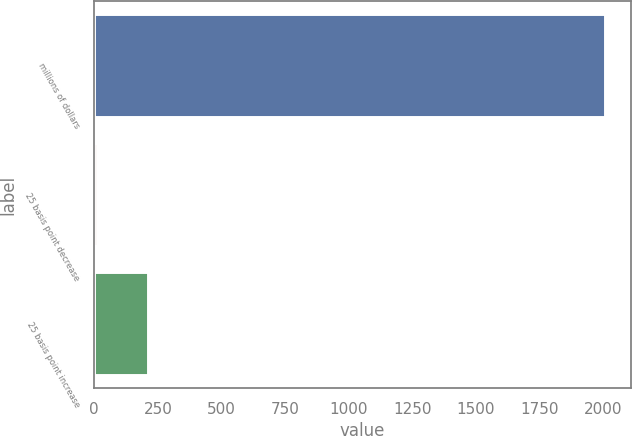Convert chart to OTSL. <chart><loc_0><loc_0><loc_500><loc_500><bar_chart><fcel>millions of dollars<fcel>25 basis point decrease<fcel>25 basis point increase<nl><fcel>2009<fcel>9.9<fcel>209.81<nl></chart> 